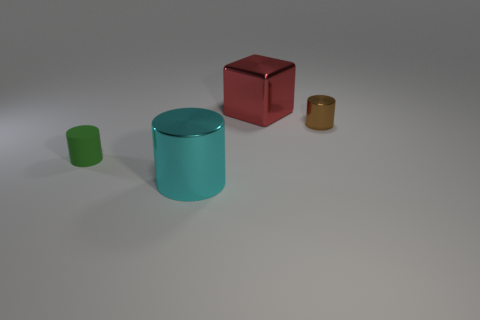Subtract all tiny green cylinders. How many cylinders are left? 2 Add 2 tiny green cylinders. How many objects exist? 6 Subtract all brown cylinders. How many cylinders are left? 2 Subtract 1 cylinders. How many cylinders are left? 2 Add 1 cyan metal cylinders. How many cyan metal cylinders are left? 2 Add 1 purple metallic cylinders. How many purple metallic cylinders exist? 1 Subtract 0 purple cubes. How many objects are left? 4 Subtract all cubes. How many objects are left? 3 Subtract all blue blocks. Subtract all red balls. How many blocks are left? 1 Subtract all green cylinders. How many yellow cubes are left? 0 